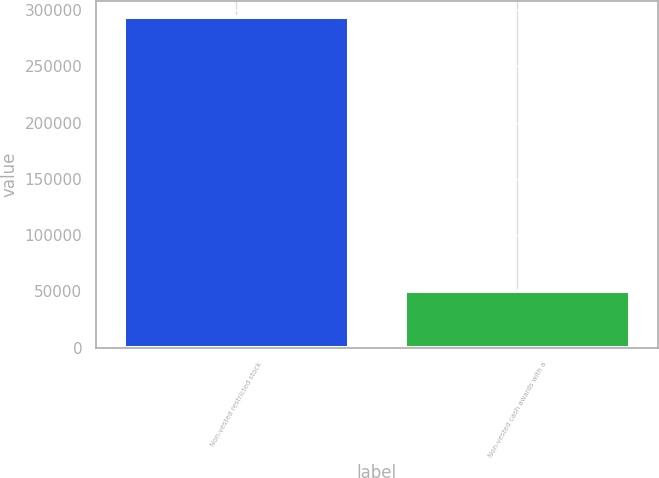Convert chart. <chart><loc_0><loc_0><loc_500><loc_500><bar_chart><fcel>Non-vested restricted stock<fcel>Non-vested cash awards with a<nl><fcel>293500<fcel>50000<nl></chart> 